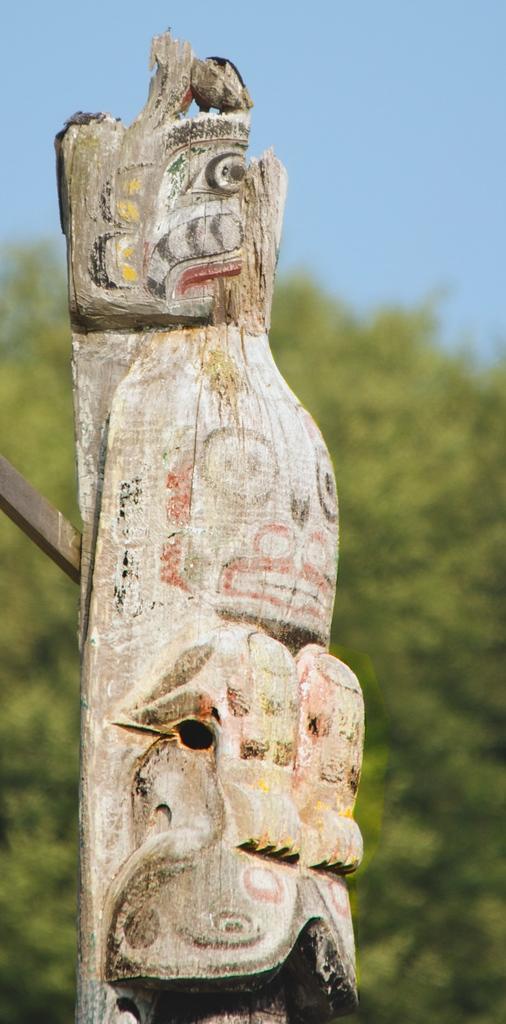How would you summarize this image in a sentence or two? This image consists of a wooden block which is shaped and chiseled. In the background, there are trees. At the top, there is sky. The background, is blurred. 